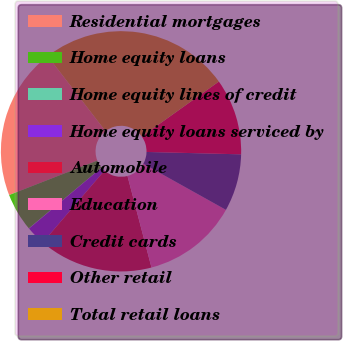<chart> <loc_0><loc_0><loc_500><loc_500><pie_chart><fcel>Residential mortgages<fcel>Home equity loans<fcel>Home equity lines of credit<fcel>Home equity loans serviced by<fcel>Automobile<fcel>Education<fcel>Credit cards<fcel>Other retail<fcel>Total retail loans<nl><fcel>20.48%<fcel>5.15%<fcel>0.04%<fcel>2.59%<fcel>15.37%<fcel>12.82%<fcel>7.7%<fcel>10.26%<fcel>25.59%<nl></chart> 